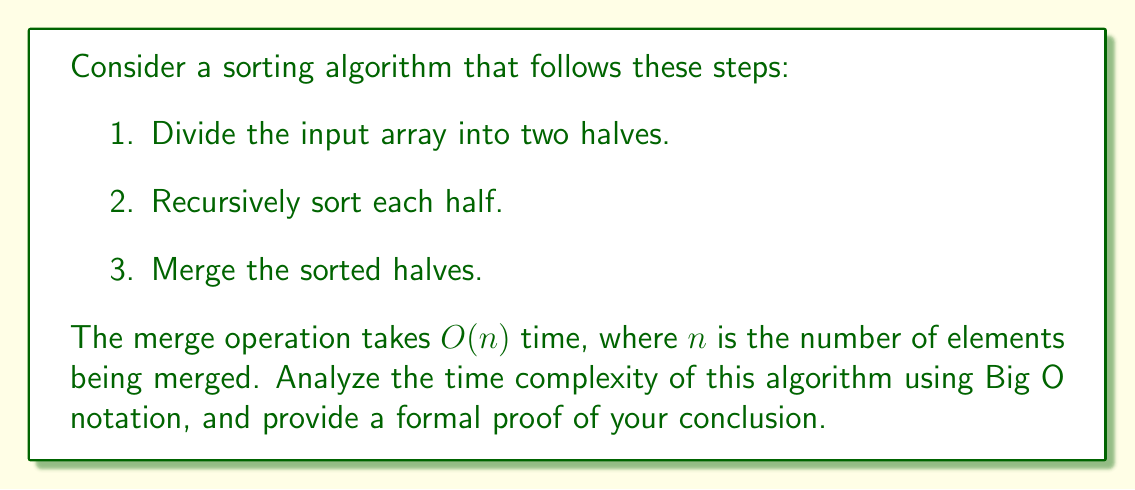Help me with this question. To analyze the time complexity of this algorithm, we'll follow a systematic approach:

1. Formulate the recurrence relation:
   Let $T(n)$ be the time complexity for an input of size $n$.
   $$T(n) = 2T(n/2) + O(n)$$
   This is because we divide the problem into two subproblems of size $n/2$, and the merge step takes $O(n)$ time.

2. Apply the Master Theorem:
   The Master Theorem states that for recurrences of the form:
   $$T(n) = aT(n/b) + f(n)$$
   where $a \geq 1$, $b > 1$, and $f(n)$ is a positive function, we compare $n^{\log_b a}$ with $f(n)$.

   In our case, $a = 2$, $b = 2$, and $f(n) = O(n)$.

3. Calculate $n^{\log_b a}$:
   $$n^{\log_2 2} = n^1 = n$$

4. Compare $n^{\log_b a}$ with $f(n)$:
   $n^{\log_b a} = n$ and $f(n) = O(n)$
   Since they are of the same order, we fall into case 2 of the Master Theorem.

5. Apply case 2 of the Master Theorem:
   When $n^{\log_b a} = \Theta(f(n) \log^k n)$ for some $k \geq 0$, the solution is:
   $$T(n) = \Theta(n^{\log_b a} \log n) = \Theta(n \log n)$$

6. Formal proof:
   To prove this formally, we can use the substitution method:
   Assume $T(n) \leq cn \log n$ for some constant $c > 0$.
   
   $$\begin{align}
   T(n) &\leq 2T(n/2) + dn \quad \text{(for some constant } d > 0)\\
        &\leq 2(c(n/2) \log(n/2)) + dn\\
        &= cn \log(n/2) + dn\\
        &= cn \log n - cn \log 2 + dn\\
        &= cn \log n - cn(1) + dn\\
        &= cn \log n + (d-c)n
   \end{align}$$

   For this to be $\leq cn \log n$, we need:
   $$(d-c)n \leq 0$$
   $$c \geq d$$

   By choosing $c \geq d$, we prove that $T(n) = O(n \log n)$.

   A similar proof can be constructed for the lower bound, showing $T(n) = \Omega(n \log n)$.

Therefore, we conclude that $T(n) = \Theta(n \log n)$.
Answer: The time complexity of the given sorting algorithm is $\Theta(n \log n)$. 